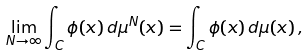Convert formula to latex. <formula><loc_0><loc_0><loc_500><loc_500>\lim _ { N \to \infty } \int _ { C } \phi ( x ) \, d \mu ^ { N } ( x ) = \int _ { C } \phi ( x ) \, d \mu ( x ) \, ,</formula> 